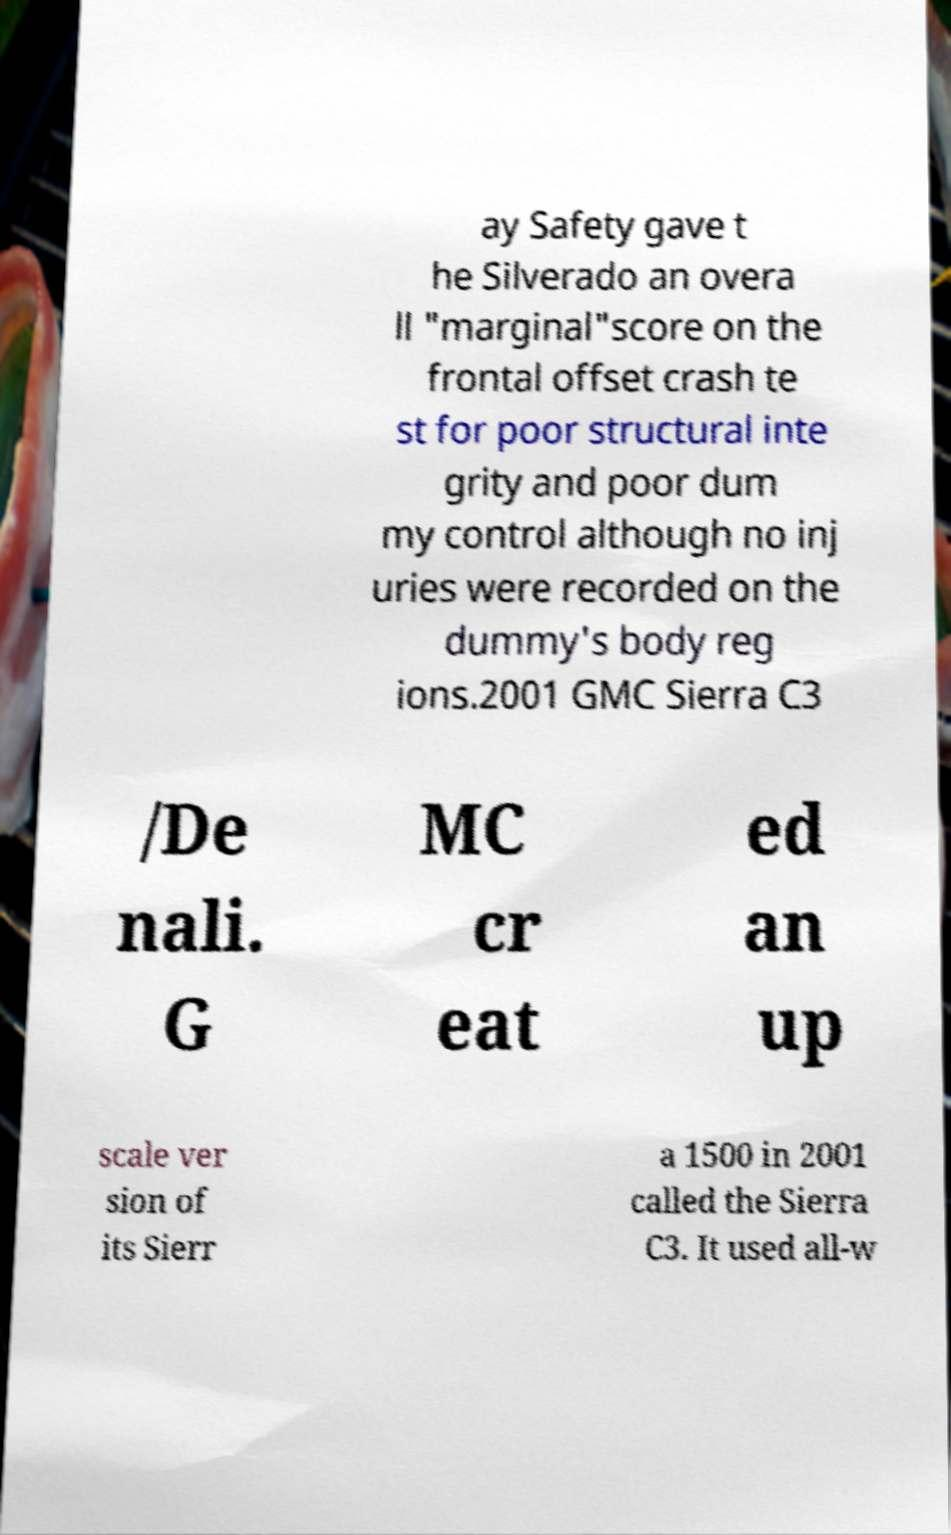Could you assist in decoding the text presented in this image and type it out clearly? ay Safety gave t he Silverado an overa ll "marginal"score on the frontal offset crash te st for poor structural inte grity and poor dum my control although no inj uries were recorded on the dummy's body reg ions.2001 GMC Sierra C3 /De nali. G MC cr eat ed an up scale ver sion of its Sierr a 1500 in 2001 called the Sierra C3. It used all-w 